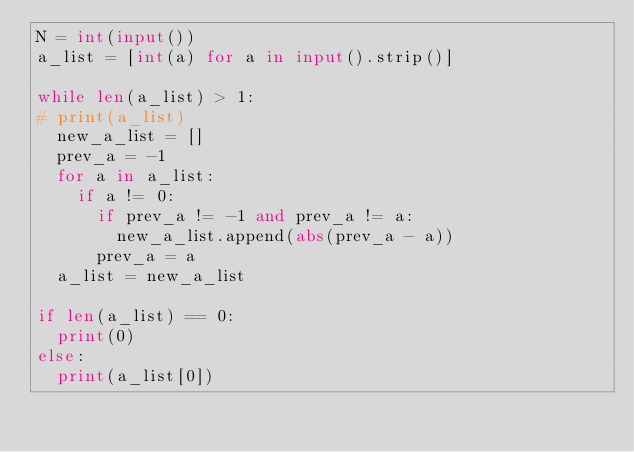Convert code to text. <code><loc_0><loc_0><loc_500><loc_500><_Python_>N = int(input())
a_list = [int(a) for a in input().strip()]

while len(a_list) > 1:
#	print(a_list)
	new_a_list = []
	prev_a = -1
	for a in a_list:
		if a != 0:
			if prev_a != -1 and prev_a != a:
				new_a_list.append(abs(prev_a - a))
			prev_a = a
	a_list = new_a_list

if len(a_list) == 0:
	print(0)
else:
	print(a_list[0])
</code> 